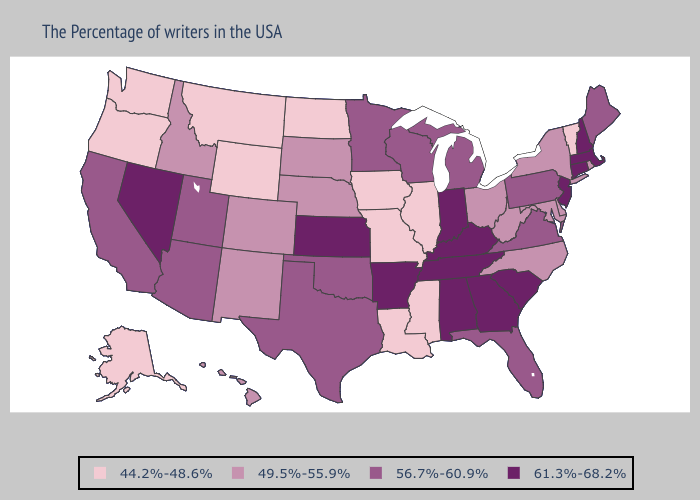Does Virginia have a lower value than Oklahoma?
Give a very brief answer. No. Does Iowa have a lower value than Wyoming?
Answer briefly. No. Does the first symbol in the legend represent the smallest category?
Give a very brief answer. Yes. Does Missouri have the same value as Montana?
Quick response, please. Yes. Name the states that have a value in the range 44.2%-48.6%?
Keep it brief. Vermont, Illinois, Mississippi, Louisiana, Missouri, Iowa, North Dakota, Wyoming, Montana, Washington, Oregon, Alaska. What is the lowest value in the West?
Short answer required. 44.2%-48.6%. Does North Dakota have the lowest value in the MidWest?
Concise answer only. Yes. Name the states that have a value in the range 49.5%-55.9%?
Write a very short answer. Rhode Island, New York, Delaware, Maryland, North Carolina, West Virginia, Ohio, Nebraska, South Dakota, Colorado, New Mexico, Idaho, Hawaii. Which states have the lowest value in the South?
Quick response, please. Mississippi, Louisiana. How many symbols are there in the legend?
Answer briefly. 4. How many symbols are there in the legend?
Be succinct. 4. Is the legend a continuous bar?
Be succinct. No. What is the highest value in states that border Wisconsin?
Be succinct. 56.7%-60.9%. Does the first symbol in the legend represent the smallest category?
Write a very short answer. Yes. 